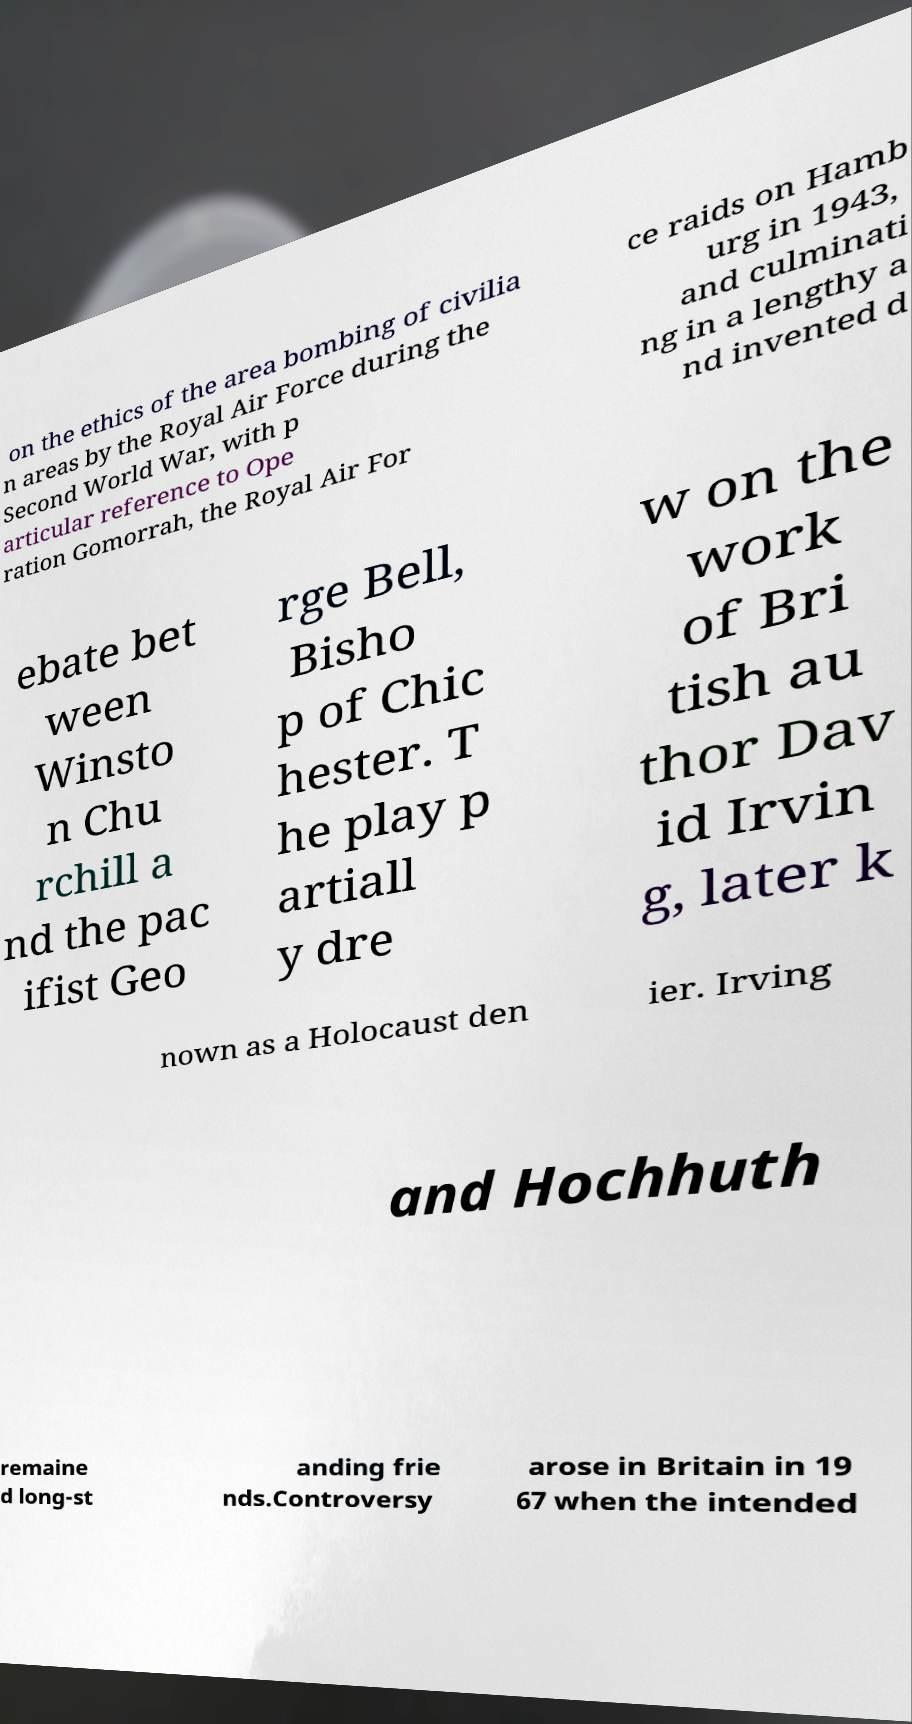Can you read and provide the text displayed in the image?This photo seems to have some interesting text. Can you extract and type it out for me? on the ethics of the area bombing of civilia n areas by the Royal Air Force during the Second World War, with p articular reference to Ope ration Gomorrah, the Royal Air For ce raids on Hamb urg in 1943, and culminati ng in a lengthy a nd invented d ebate bet ween Winsto n Chu rchill a nd the pac ifist Geo rge Bell, Bisho p of Chic hester. T he play p artiall y dre w on the work of Bri tish au thor Dav id Irvin g, later k nown as a Holocaust den ier. Irving and Hochhuth remaine d long-st anding frie nds.Controversy arose in Britain in 19 67 when the intended 